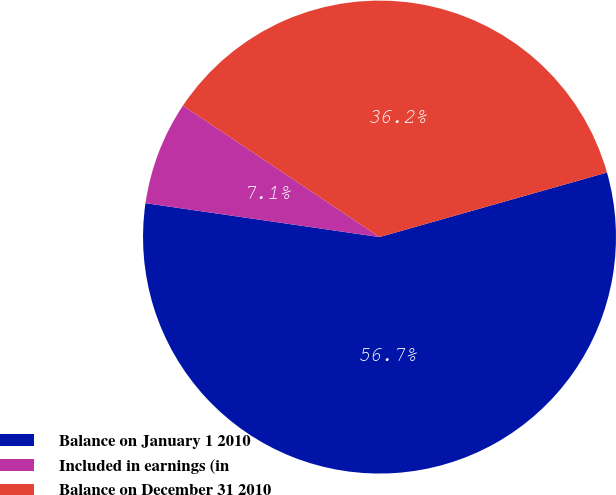Convert chart. <chart><loc_0><loc_0><loc_500><loc_500><pie_chart><fcel>Balance on January 1 2010<fcel>Included in earnings (in<fcel>Balance on December 31 2010<nl><fcel>56.69%<fcel>7.09%<fcel>36.22%<nl></chart> 